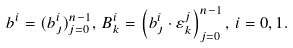<formula> <loc_0><loc_0><loc_500><loc_500>b ^ { i } = ( b _ { \jmath } ^ { i } ) _ { j = 0 } ^ { n - 1 } , \, B _ { k } ^ { i } = \left ( b _ { \jmath } ^ { i } \cdot \varepsilon _ { k } ^ { j } \right ) _ { j = 0 } ^ { n - 1 } , \, i = 0 , 1 .</formula> 